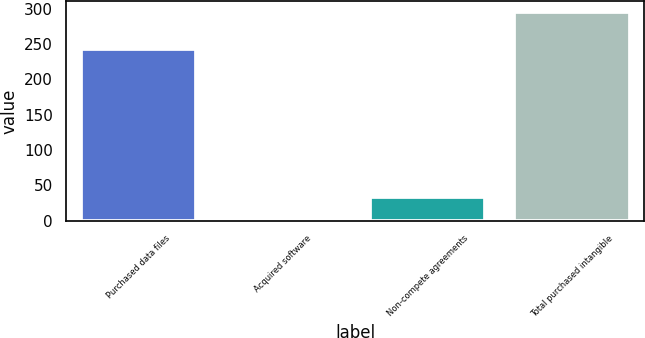Convert chart to OTSL. <chart><loc_0><loc_0><loc_500><loc_500><bar_chart><fcel>Purchased data files<fcel>Acquired software<fcel>Non-compete agreements<fcel>Total purchased intangible<nl><fcel>243.3<fcel>4.2<fcel>33.4<fcel>296.2<nl></chart> 